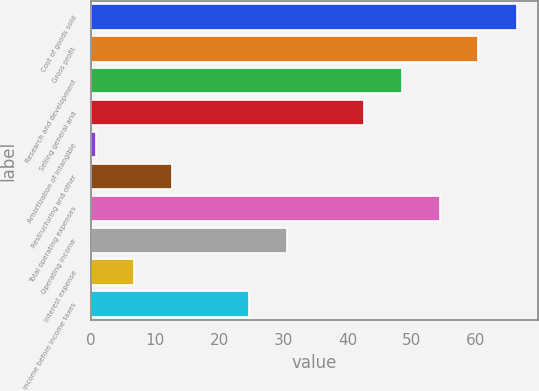<chart> <loc_0><loc_0><loc_500><loc_500><bar_chart><fcel>Cost of goods sold<fcel>Gross profit<fcel>Research and development<fcel>Selling general and<fcel>Amortization of intangible<fcel>Restructuring and other<fcel>Total operating expenses<fcel>Operating income<fcel>Interest expense<fcel>Income before income taxes<nl><fcel>66.36<fcel>60.4<fcel>48.48<fcel>42.52<fcel>0.8<fcel>12.72<fcel>54.44<fcel>30.6<fcel>6.76<fcel>24.64<nl></chart> 